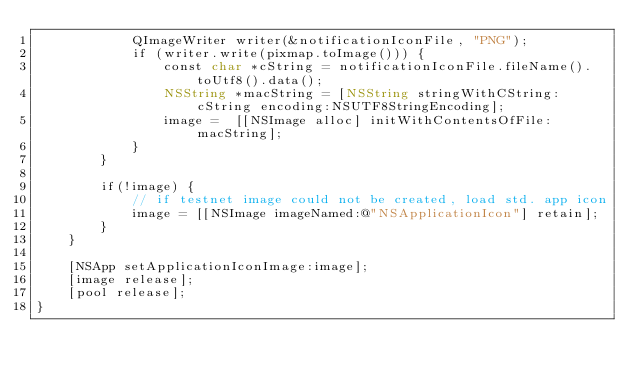Convert code to text. <code><loc_0><loc_0><loc_500><loc_500><_ObjectiveC_>            QImageWriter writer(&notificationIconFile, "PNG");
            if (writer.write(pixmap.toImage())) {
                const char *cString = notificationIconFile.fileName().toUtf8().data();
                NSString *macString = [NSString stringWithCString:cString encoding:NSUTF8StringEncoding];
                image =  [[NSImage alloc] initWithContentsOfFile:macString];
            }
        }

        if(!image) {
            // if testnet image could not be created, load std. app icon
            image = [[NSImage imageNamed:@"NSApplicationIcon"] retain];
        }
    }

    [NSApp setApplicationIconImage:image];
    [image release];
    [pool release];
}
</code> 